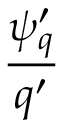Convert formula to latex. <formula><loc_0><loc_0><loc_500><loc_500>\frac { { \psi } _ { q } ^ { \prime } } { q ^ { \prime } }</formula> 